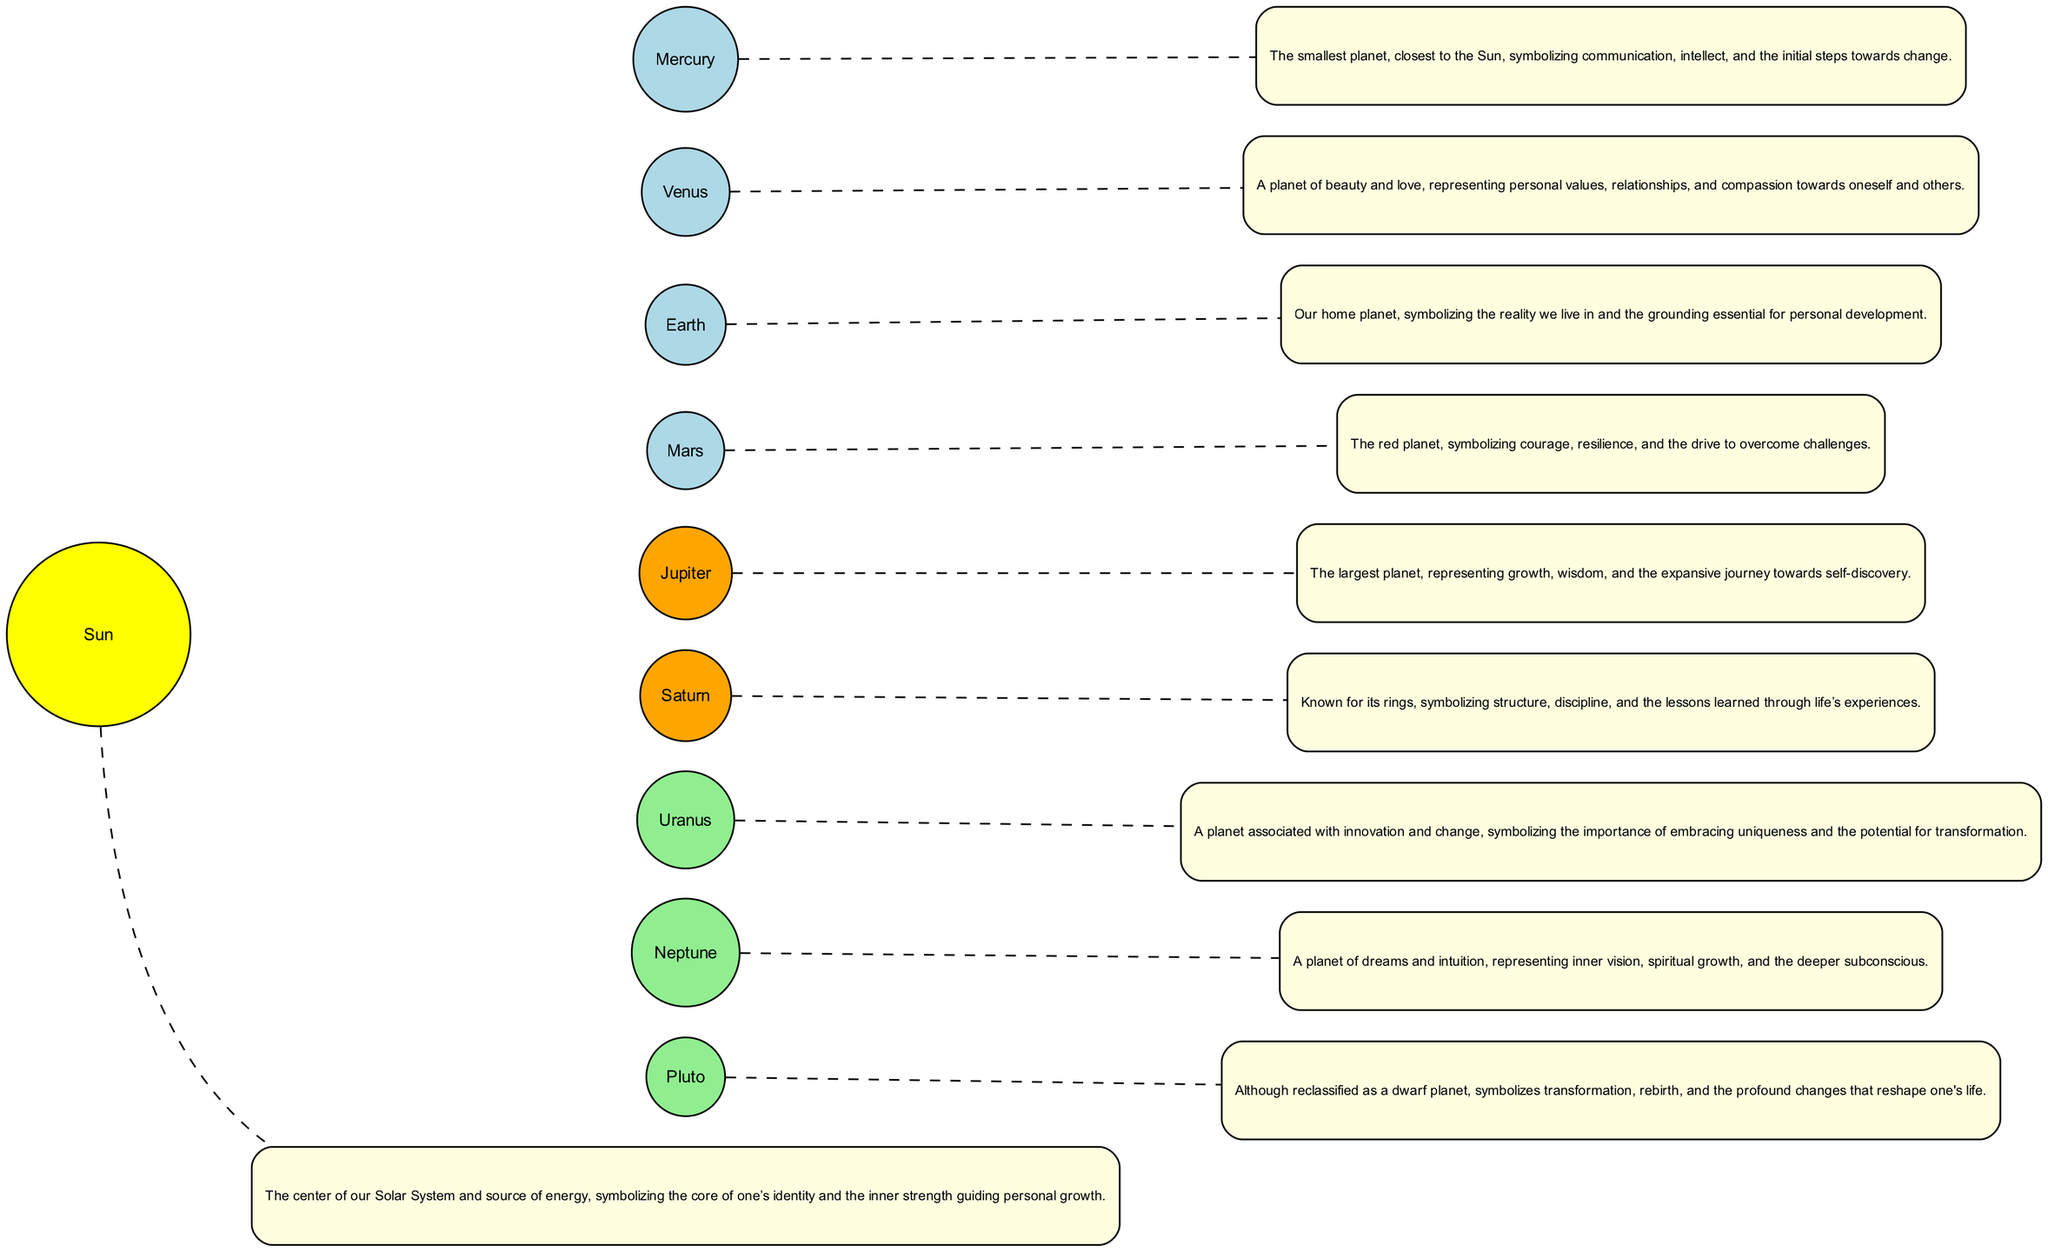What celestial body is at the center of the Solar System? The diagram indicates that the Sun is in the center, as it is the primary source of energy and the main focus around which all other celestial bodies orbit.
Answer: Sun How many planets are represented in the diagram? By counting the nodes besides the Sun, we find a total of eight planets (Mercury, Venus, Earth, Mars, Jupiter, Saturn, Uranus, and Neptune) plus Pluto, which makes it nine.
Answer: Nine Which planet symbolizes courage and resilience? The diagram includes details indicating that Mars, the red planet, is associated with courage and resilience.
Answer: Mars What color represents Jupiter in the diagram? The diagram specifies that Jupiter is colored orange, which denotes its representation in the visual layout of the Solar System.
Answer: Orange What metaphorical role does Neptune play according to the description? Neptune is described as representing inner vision, spiritual growth, and the deeper subconscious, based on the information conveyed in its corresponding node.
Answer: Inner vision What qualities does Venus symbolize? According to the diagram, Venus symbolizes beauty, love, personal values, relationships, and compassion towards oneself and others.
Answer: Beauty and love Which celestial body is associated with structure and discipline? The diagram notes that Saturn, known for its rings, symbolizes structure and discipline, reflecting the lessons learned through life.
Answer: Saturn What transformation does Pluto represent in the Solar System metaphor? The description of Pluto highlights its symbolism for transformation, rebirth, and profound changes that significantly impact an individual's life journey.
Answer: Transformation 